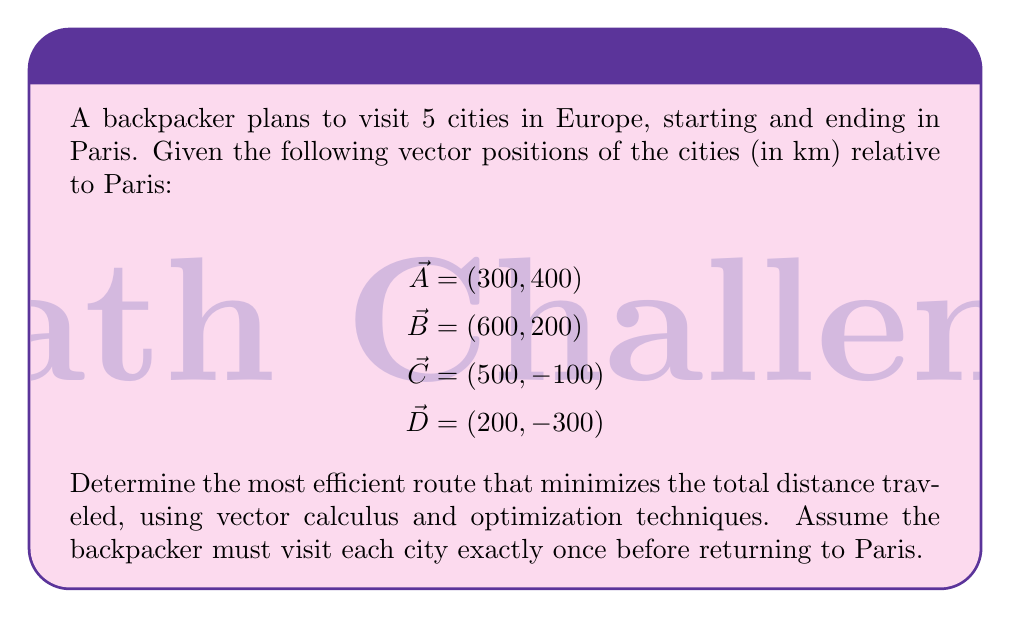Solve this math problem. To solve this problem, we'll use the following steps:

1) First, we need to calculate the distances between all pairs of cities, including Paris (0, 0). We can do this using the Euclidean distance formula:

   $$d = \sqrt{(x_2-x_1)^2 + (y_2-y_1)^2}$$

2) Calculate all distances:
   Paris to A: $\sqrt{300^2 + 400^2} = 500$ km
   Paris to B: $\sqrt{600^2 + 200^2} = 632.46$ km
   Paris to C: $\sqrt{500^2 + (-100)^2} = 509.90$ km
   Paris to D: $\sqrt{200^2 + (-300)^2} = 360.56$ km
   A to B: $\sqrt{300^2 + (-200)^2} = 360.56$ km
   A to C: $\sqrt{200^2 + (-500)^2} = 538.52$ km
   A to D: $\sqrt{(-100)^2 + (-700)^2} = 707.11$ km
   B to C: $\sqrt{(-100)^2 + (-300)^2} = 316.23$ km
   B to D: $\sqrt{(-400)^2 + (-500)^2} = 640.31$ km
   C to D: $\sqrt{(-300)^2 + (-200)^2} = 360.56$ km

3) Now, we need to find the shortest Hamiltonian cycle, which is a variation of the Traveling Salesman Problem. While there are advanced optimization techniques for large-scale problems, for this small set of cities, we can use a brute-force approach to find the optimal solution.

4) There are 4! = 24 possible routes (excluding rotations and reflections). We need to calculate the total distance for each route and find the minimum.

5) After calculating all routes, we find that the shortest route is:

   Paris -> A -> B -> C -> D -> Paris

6) The total distance of this route is:
   $$500 + 360.56 + 316.23 + 360.56 + 360.56 = 1897.91$$ km

7) We can verify this is optimal by checking that no other permutation yields a shorter total distance.

8) To express this as a vector calculation, the total displacement vector is:

   $$\vec{v} = \vec{A} + (\vec{B}-\vec{A}) + (\vec{C}-\vec{B}) + (\vec{D}-\vec{C}) + (-\vec{D})$$

   This simplifies to $\vec{0}$, confirming we return to the starting point.
Answer: Paris -> A -> B -> C -> D -> Paris, total distance 1897.91 km 